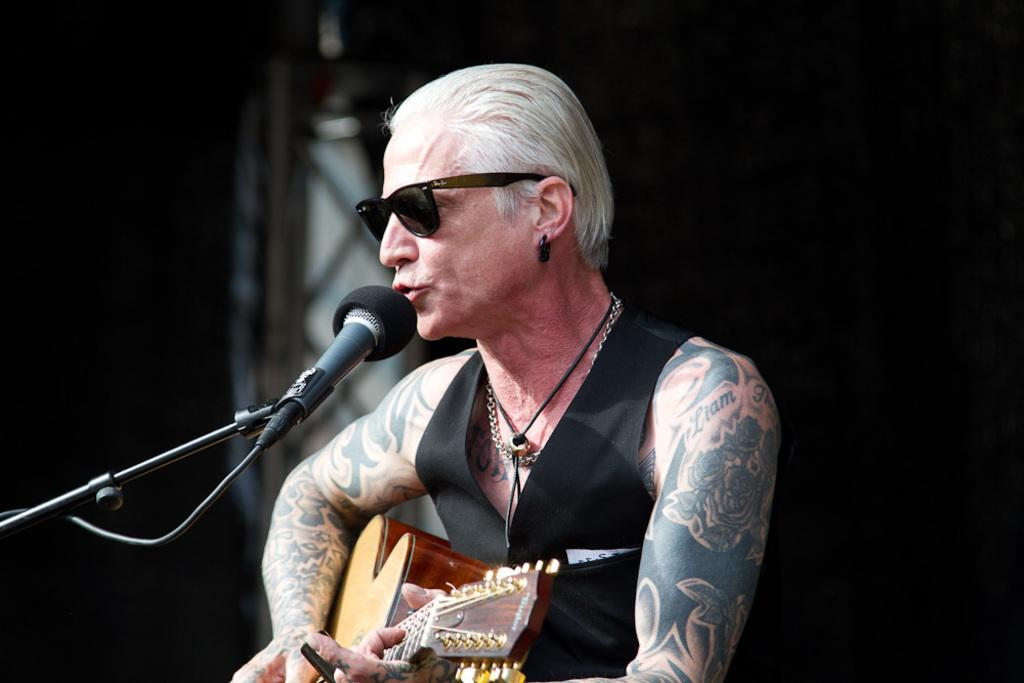What is the man in the image doing? The man is playing a guitar and singing. How is the man amplifying his voice in the image? The man is using a microphone. What type of banana is the man using as a prop in the image? There is no banana present in the image; the man is playing a guitar and singing. 